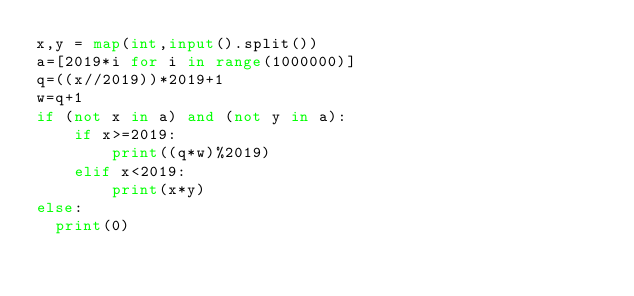Convert code to text. <code><loc_0><loc_0><loc_500><loc_500><_Python_>x,y = map(int,input().split())
a=[2019*i for i in range(1000000)]
q=((x//2019))*2019+1
w=q+1
if (not x in a) and (not y in a):
	if x>=2019:
		print((q*w)%2019)
	elif x<2019:
		print(x*y)
else:
  print(0)  </code> 